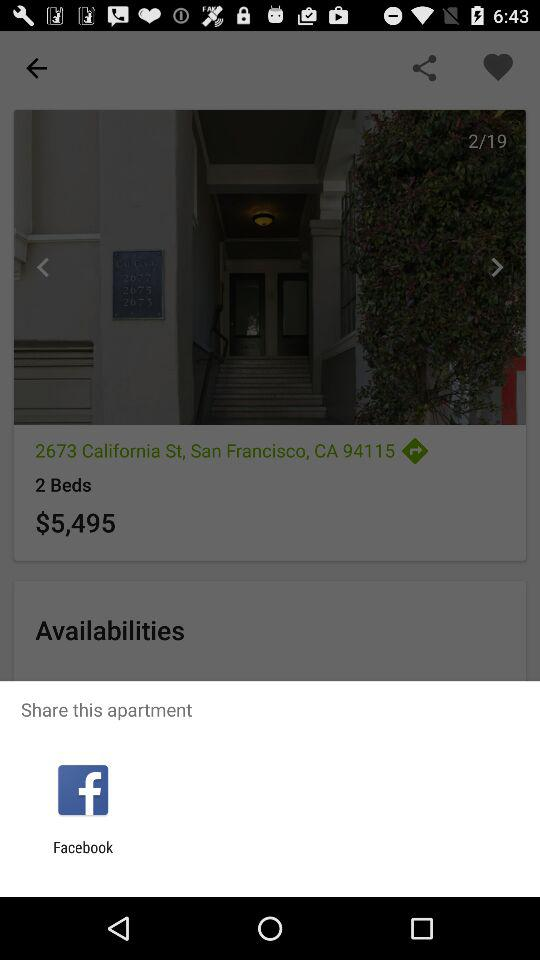Through what app can we share this apartment? You can share it on "Facebook". 